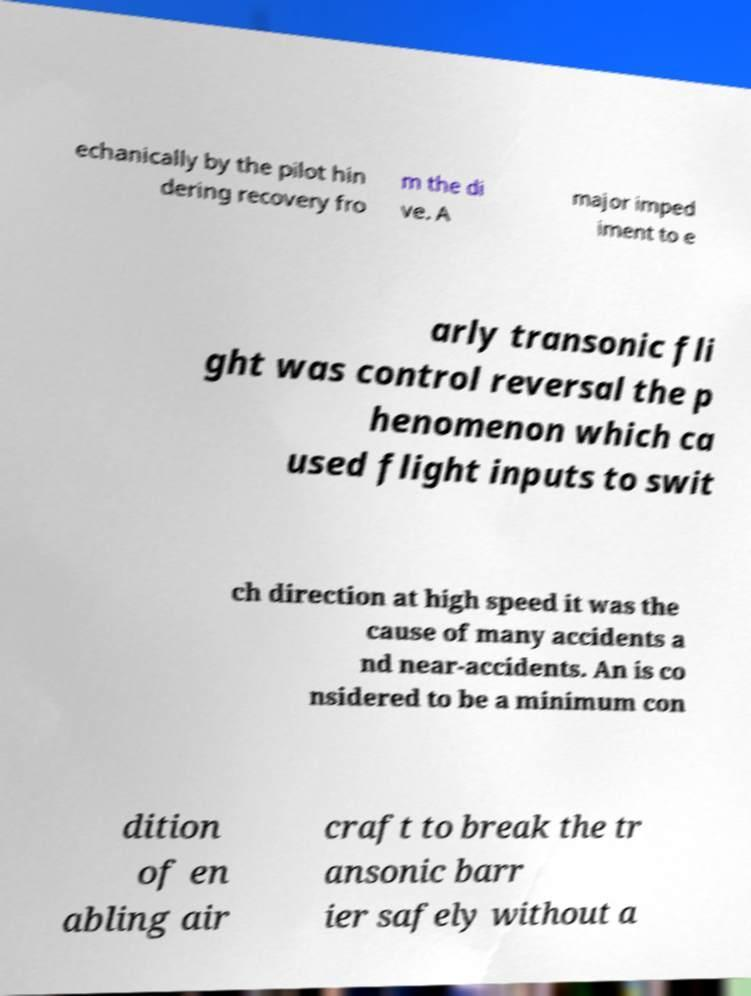I need the written content from this picture converted into text. Can you do that? echanically by the pilot hin dering recovery fro m the di ve. A major imped iment to e arly transonic fli ght was control reversal the p henomenon which ca used flight inputs to swit ch direction at high speed it was the cause of many accidents a nd near-accidents. An is co nsidered to be a minimum con dition of en abling air craft to break the tr ansonic barr ier safely without a 